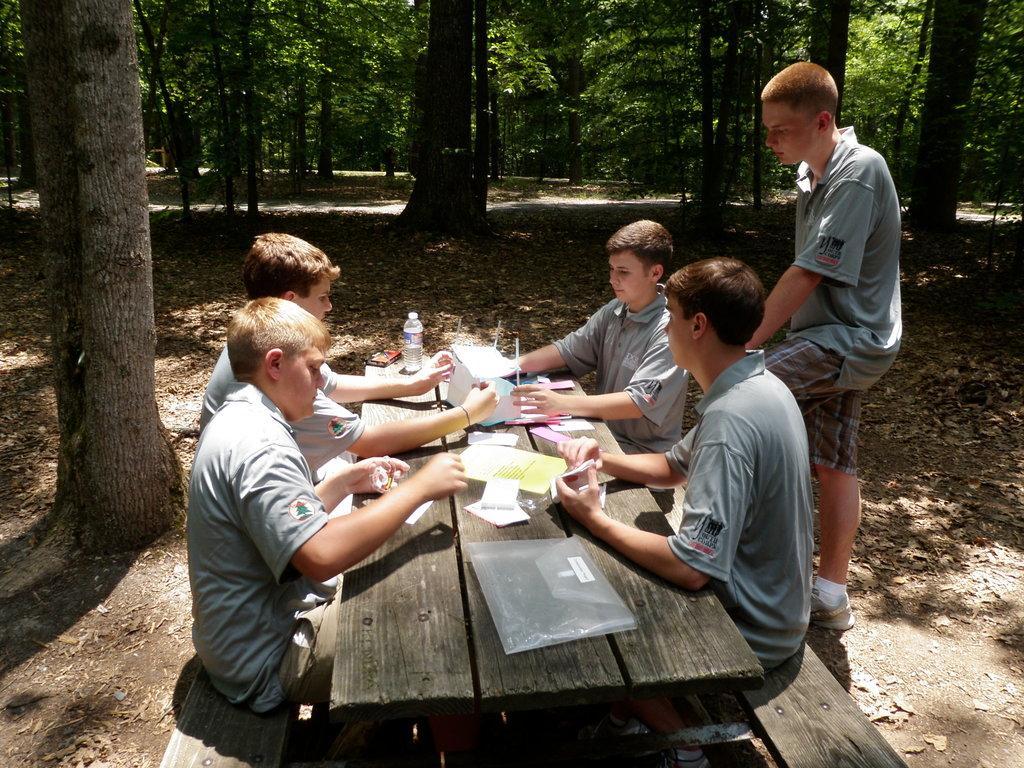How would you summarize this image in a sentence or two? In this image I can see four people sitting in front of the table and one person is standing. On the table there are some papers and bottles. In the background there are trees. 